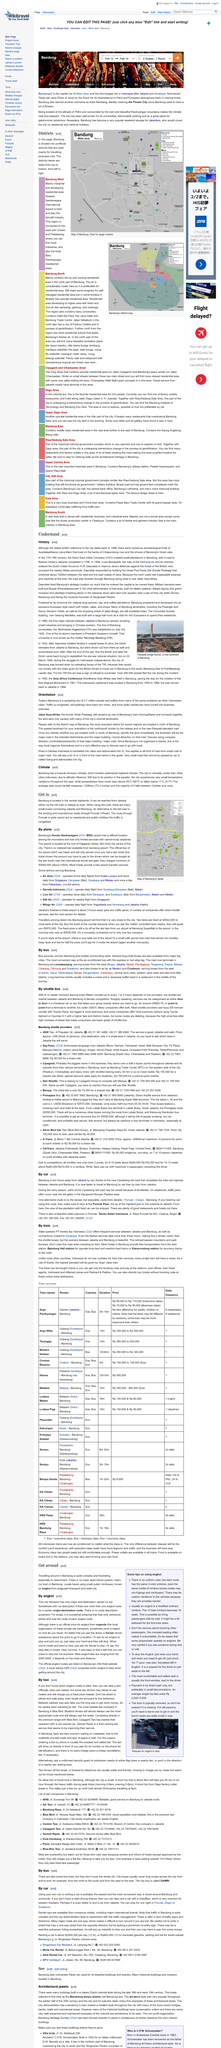Give some essential details in this illustration. The topic of the page is clearly climate. I have observed that angkots typically have 18 seats. It is recommended to use the gesture of raising one's hand to stop an Angkut. Bandung experiences a tropical monsoon climate, characterized by a rainy season from April to October and a dry season from November to March. There is a tropical monsoon climate in Bandung, characterized by high temperatures and humidity throughout the year. 